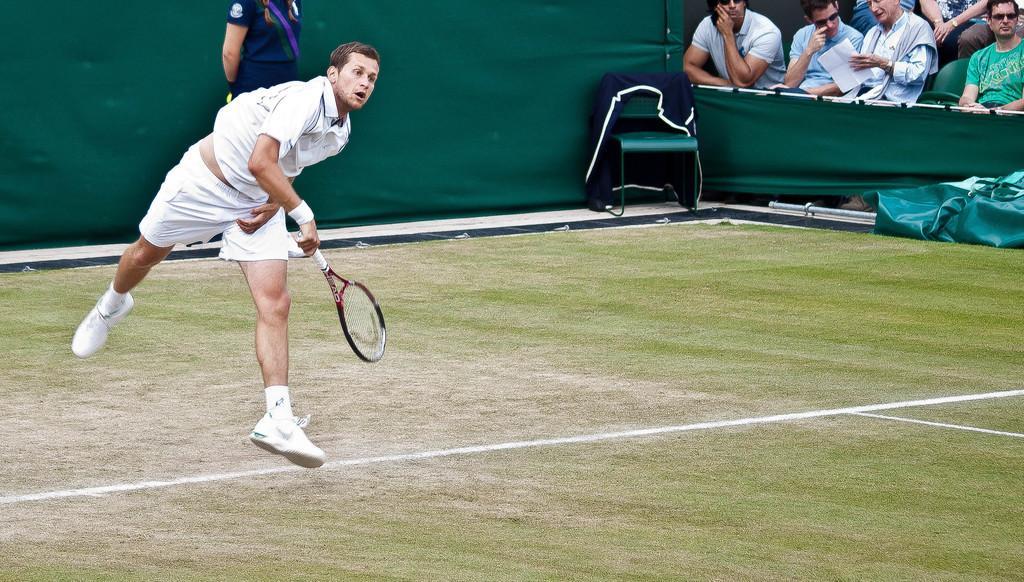How would you summarize this image in a sentence or two? In this image there is a person wearing white color sports dress holding racket in his hand and at the right side of the image there are spectators and at the background of the image there is a lady person standing. 